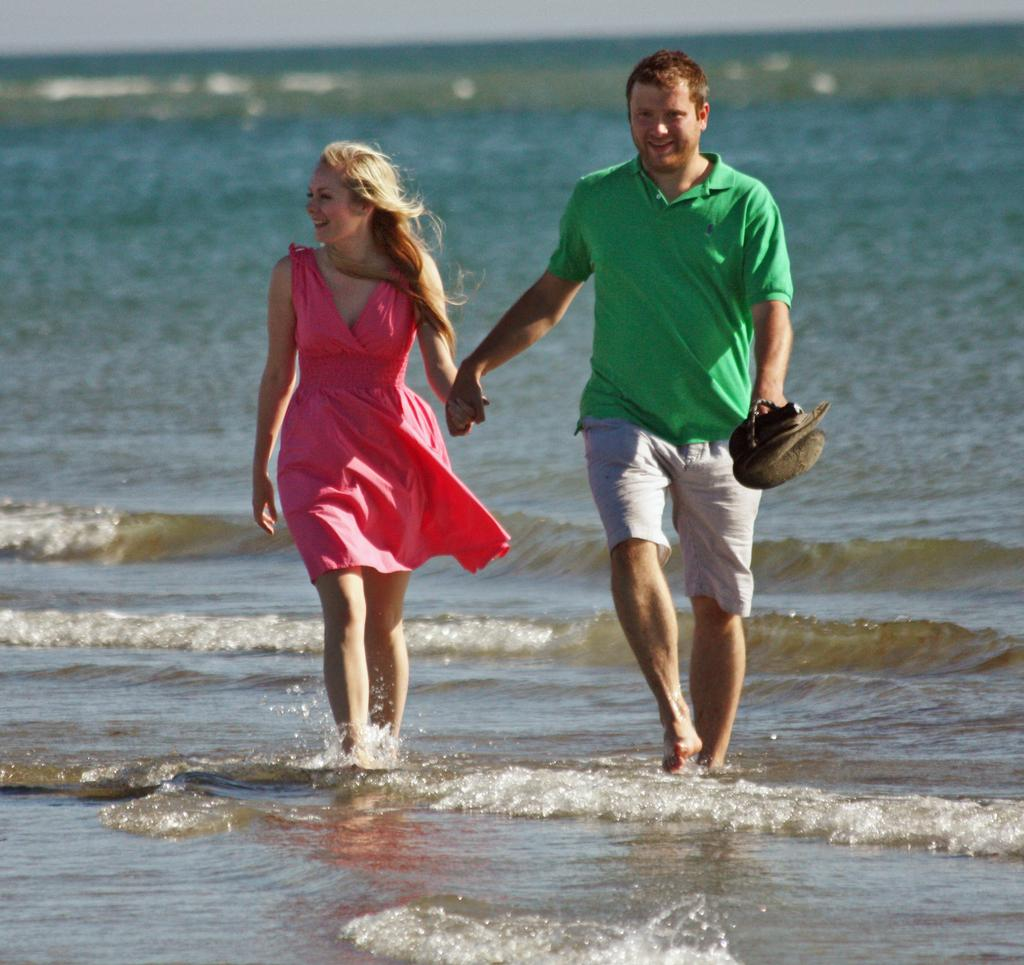What are the two people in the image doing? A: A couple is walking in the image. What can be seen in the background of the image? There is water visible in the image. What is the person at the right wearing? The person at the right is wearing a green t-shirt and shorts. What is the person at the left wearing? The person at the left is wearing a pink dress. What is the person at the right holding in their hand? The person at the right is holding something in their hand, but we cannot determine what it is from the image. What type of potato is being used as a prop in the image? There is no potato present in the image. What is the purpose of the journey depicted in the image? There is no journey depicted in the image; it simply shows a couple walking. 